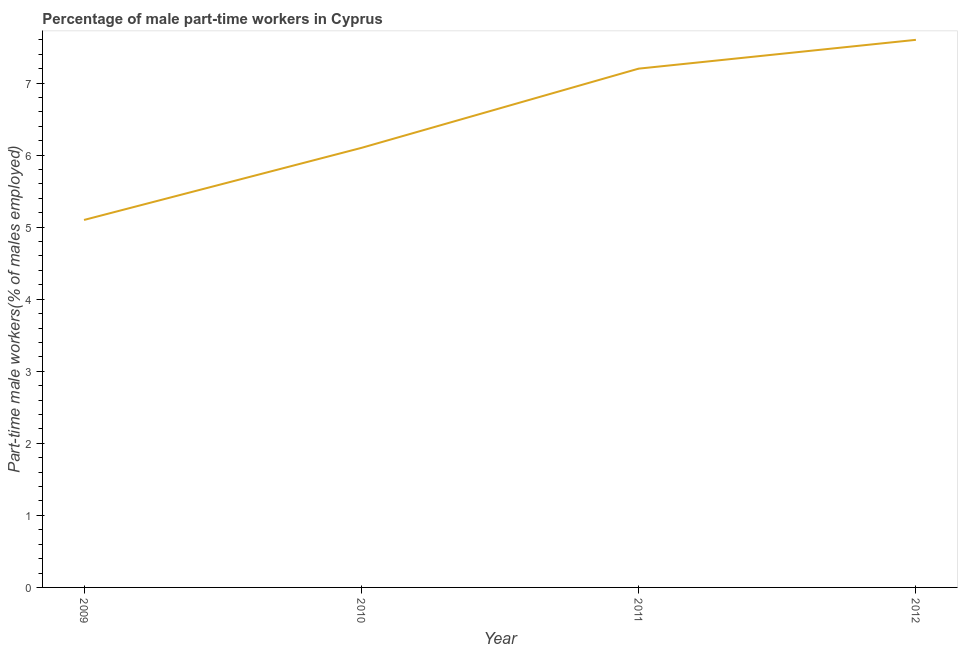What is the percentage of part-time male workers in 2011?
Provide a short and direct response. 7.2. Across all years, what is the maximum percentage of part-time male workers?
Offer a very short reply. 7.6. Across all years, what is the minimum percentage of part-time male workers?
Your answer should be very brief. 5.1. In which year was the percentage of part-time male workers maximum?
Your response must be concise. 2012. In which year was the percentage of part-time male workers minimum?
Make the answer very short. 2009. What is the sum of the percentage of part-time male workers?
Offer a terse response. 26. What is the difference between the percentage of part-time male workers in 2010 and 2012?
Offer a very short reply. -1.5. What is the average percentage of part-time male workers per year?
Offer a terse response. 6.5. What is the median percentage of part-time male workers?
Keep it short and to the point. 6.65. Do a majority of the years between 2009 and 2012 (inclusive) have percentage of part-time male workers greater than 1.8 %?
Provide a short and direct response. Yes. What is the ratio of the percentage of part-time male workers in 2009 to that in 2010?
Ensure brevity in your answer.  0.84. Is the difference between the percentage of part-time male workers in 2011 and 2012 greater than the difference between any two years?
Your answer should be compact. No. What is the difference between the highest and the second highest percentage of part-time male workers?
Your response must be concise. 0.4. Is the sum of the percentage of part-time male workers in 2010 and 2012 greater than the maximum percentage of part-time male workers across all years?
Ensure brevity in your answer.  Yes. What is the difference between the highest and the lowest percentage of part-time male workers?
Provide a short and direct response. 2.5. How many lines are there?
Your response must be concise. 1. Does the graph contain any zero values?
Provide a short and direct response. No. Does the graph contain grids?
Offer a terse response. No. What is the title of the graph?
Provide a short and direct response. Percentage of male part-time workers in Cyprus. What is the label or title of the Y-axis?
Keep it short and to the point. Part-time male workers(% of males employed). What is the Part-time male workers(% of males employed) in 2009?
Offer a very short reply. 5.1. What is the Part-time male workers(% of males employed) in 2010?
Keep it short and to the point. 6.1. What is the Part-time male workers(% of males employed) of 2011?
Ensure brevity in your answer.  7.2. What is the Part-time male workers(% of males employed) of 2012?
Provide a short and direct response. 7.6. What is the difference between the Part-time male workers(% of males employed) in 2009 and 2010?
Ensure brevity in your answer.  -1. What is the difference between the Part-time male workers(% of males employed) in 2009 and 2012?
Your answer should be very brief. -2.5. What is the difference between the Part-time male workers(% of males employed) in 2010 and 2011?
Make the answer very short. -1.1. What is the difference between the Part-time male workers(% of males employed) in 2010 and 2012?
Your response must be concise. -1.5. What is the difference between the Part-time male workers(% of males employed) in 2011 and 2012?
Provide a succinct answer. -0.4. What is the ratio of the Part-time male workers(% of males employed) in 2009 to that in 2010?
Provide a succinct answer. 0.84. What is the ratio of the Part-time male workers(% of males employed) in 2009 to that in 2011?
Your answer should be very brief. 0.71. What is the ratio of the Part-time male workers(% of males employed) in 2009 to that in 2012?
Offer a terse response. 0.67. What is the ratio of the Part-time male workers(% of males employed) in 2010 to that in 2011?
Keep it short and to the point. 0.85. What is the ratio of the Part-time male workers(% of males employed) in 2010 to that in 2012?
Make the answer very short. 0.8. What is the ratio of the Part-time male workers(% of males employed) in 2011 to that in 2012?
Provide a succinct answer. 0.95. 